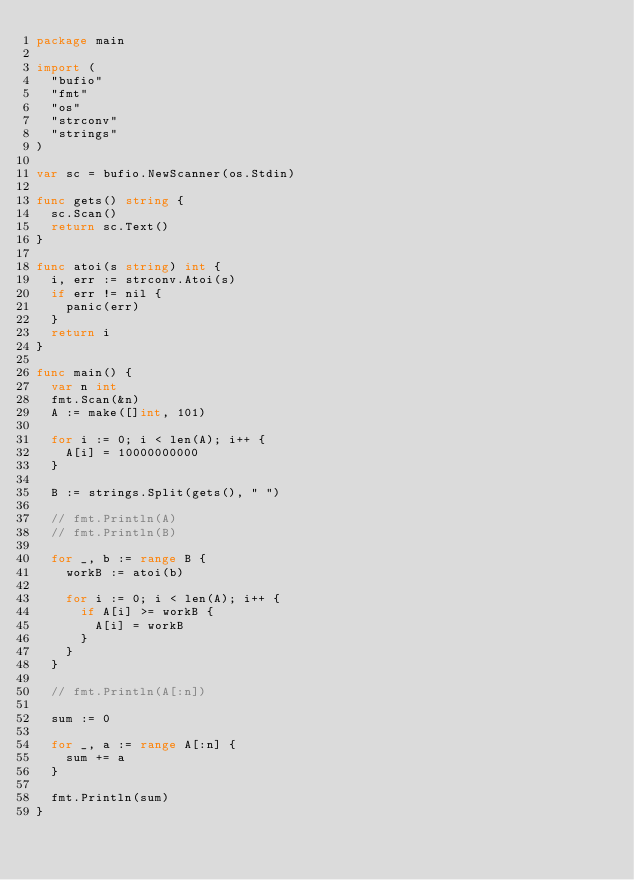<code> <loc_0><loc_0><loc_500><loc_500><_Go_>package main

import (
	"bufio"
	"fmt"
	"os"
	"strconv"
	"strings"
)

var sc = bufio.NewScanner(os.Stdin)

func gets() string {
	sc.Scan()
	return sc.Text()
}

func atoi(s string) int {
	i, err := strconv.Atoi(s)
	if err != nil {
		panic(err)
	}
	return i
}

func main() {
	var n int
	fmt.Scan(&n)
	A := make([]int, 101)

	for i := 0; i < len(A); i++ {
		A[i] = 10000000000
	}

	B := strings.Split(gets(), " ")

	// fmt.Println(A)
	// fmt.Println(B)

	for _, b := range B {
		workB := atoi(b)

		for i := 0; i < len(A); i++ {
			if A[i] >= workB {
				A[i] = workB
			}
		}
	}

	// fmt.Println(A[:n])

	sum := 0

	for _, a := range A[:n] {
		sum += a
	}

	fmt.Println(sum)
}
</code> 